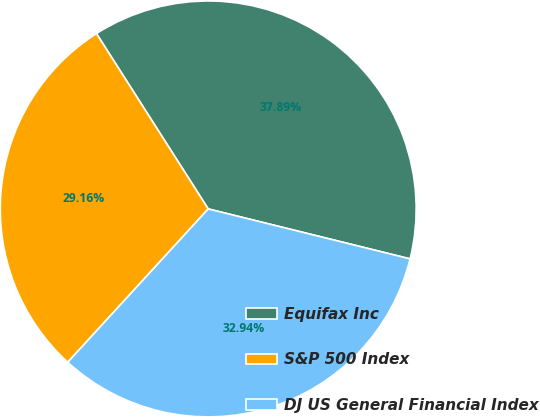Convert chart to OTSL. <chart><loc_0><loc_0><loc_500><loc_500><pie_chart><fcel>Equifax Inc<fcel>S&P 500 Index<fcel>DJ US General Financial Index<nl><fcel>37.89%<fcel>29.16%<fcel>32.94%<nl></chart> 